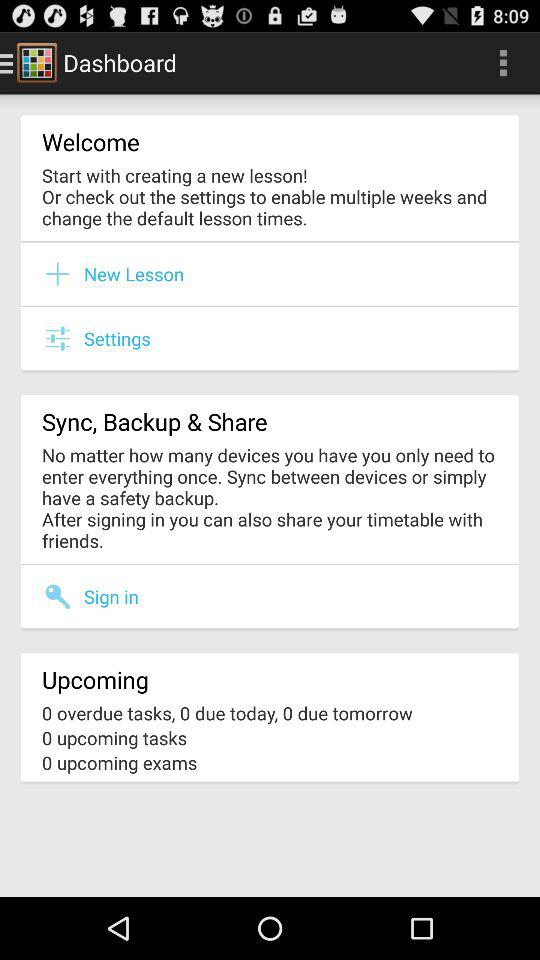How many dues are there tomorrow? There are 0 dues. 